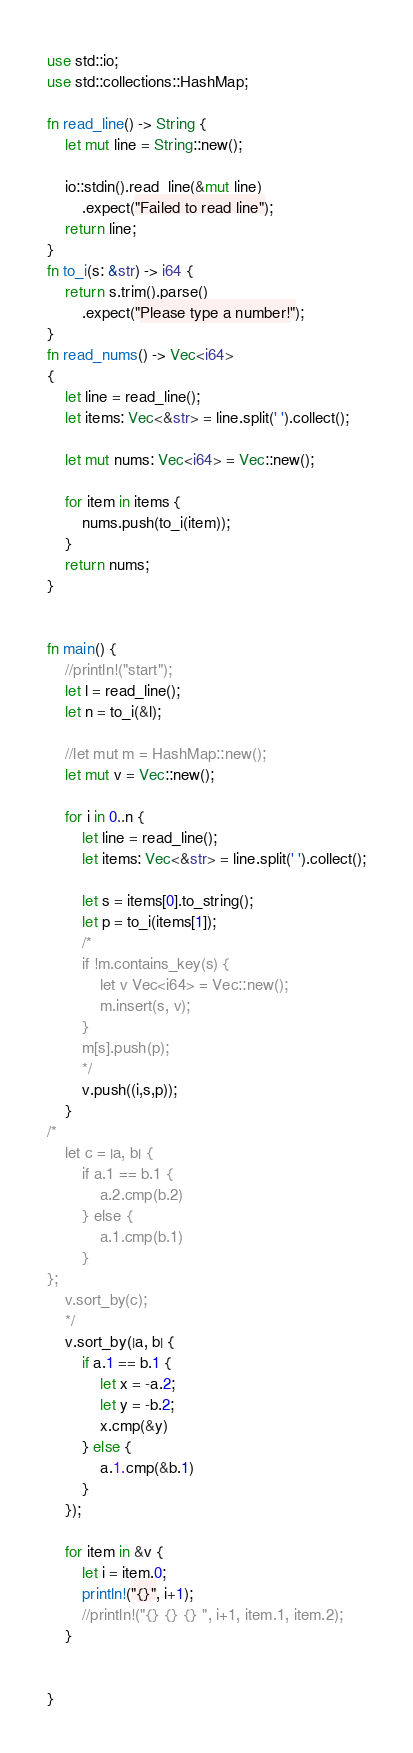<code> <loc_0><loc_0><loc_500><loc_500><_Rust_>use std::io;
use std::collections::HashMap;

fn read_line() -> String {
    let mut line = String::new();

    io::stdin().read_line(&mut line)
        .expect("Failed to read line");
    return line;
}
fn to_i(s: &str) -> i64 {
    return s.trim().parse()
        .expect("Please type a number!");
}
fn read_nums() -> Vec<i64>
{
    let line = read_line();
    let items: Vec<&str> = line.split(' ').collect();

    let mut nums: Vec<i64> = Vec::new();

    for item in items {
        nums.push(to_i(item));
    }
    return nums;
}


fn main() {
    //println!("start");
    let l = read_line();
    let n = to_i(&l);

    //let mut m = HashMap::new();
    let mut v = Vec::new();

    for i in 0..n {
        let line = read_line();
        let items: Vec<&str> = line.split(' ').collect();

        let s = items[0].to_string();
        let p = to_i(items[1]);
        /*
        if !m.contains_key(s) {
            let v Vec<i64> = Vec::new();
            m.insert(s, v);
        } 
        m[s].push(p);
        */
        v.push((i,s,p));
    }
/*
    let c = |a, b| {
        if a.1 == b.1 {
            a.2.cmp(b.2)
        } else {
            a.1.cmp(b.1)
        }
};
    v.sort_by(c);
    */
    v.sort_by(|a, b| {
        if a.1 == b.1 {
            let x = -a.2;
            let y = -b.2;
            x.cmp(&y)
        } else {
            a.1.cmp(&b.1)
        }
    });

    for item in &v {
        let i = item.0;
        println!("{}", i+1);
        //println!("{} {} {} ", i+1, item.1, item.2);
    }
    
    
}   </code> 